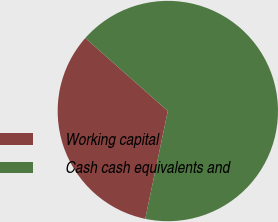Convert chart to OTSL. <chart><loc_0><loc_0><loc_500><loc_500><pie_chart><fcel>Working capital<fcel>Cash cash equivalents and<nl><fcel>33.24%<fcel>66.76%<nl></chart> 